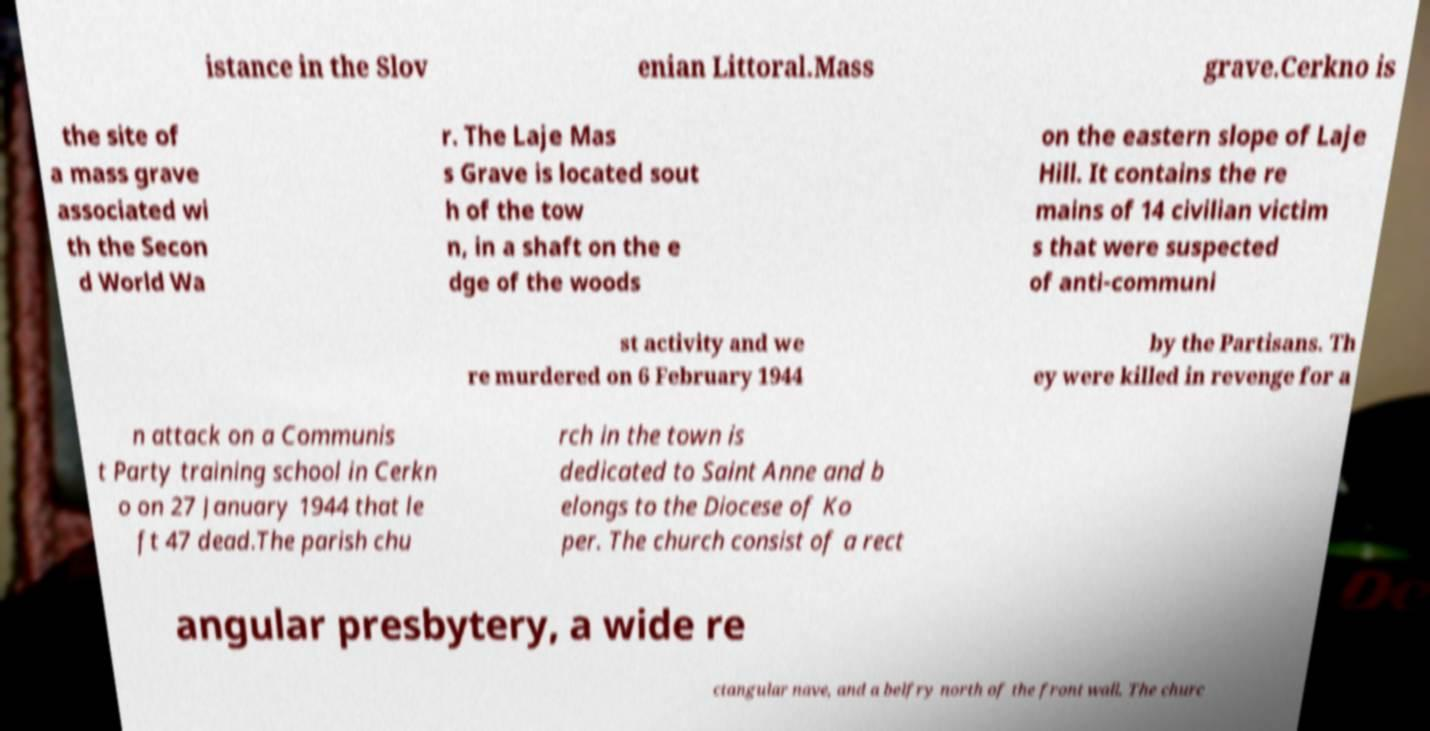Please identify and transcribe the text found in this image. istance in the Slov enian Littoral.Mass grave.Cerkno is the site of a mass grave associated wi th the Secon d World Wa r. The Laje Mas s Grave is located sout h of the tow n, in a shaft on the e dge of the woods on the eastern slope of Laje Hill. It contains the re mains of 14 civilian victim s that were suspected of anti-communi st activity and we re murdered on 6 February 1944 by the Partisans. Th ey were killed in revenge for a n attack on a Communis t Party training school in Cerkn o on 27 January 1944 that le ft 47 dead.The parish chu rch in the town is dedicated to Saint Anne and b elongs to the Diocese of Ko per. The church consist of a rect angular presbytery, a wide re ctangular nave, and a belfry north of the front wall. The churc 